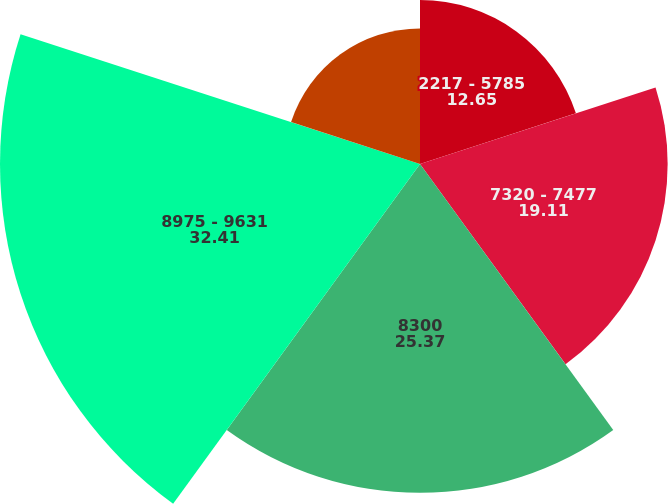Convert chart. <chart><loc_0><loc_0><loc_500><loc_500><pie_chart><fcel>2217 - 5785<fcel>7320 - 7477<fcel>8300<fcel>8975 - 9631<fcel>10213 - 11009<nl><fcel>12.65%<fcel>19.11%<fcel>25.37%<fcel>32.41%<fcel>10.46%<nl></chart> 